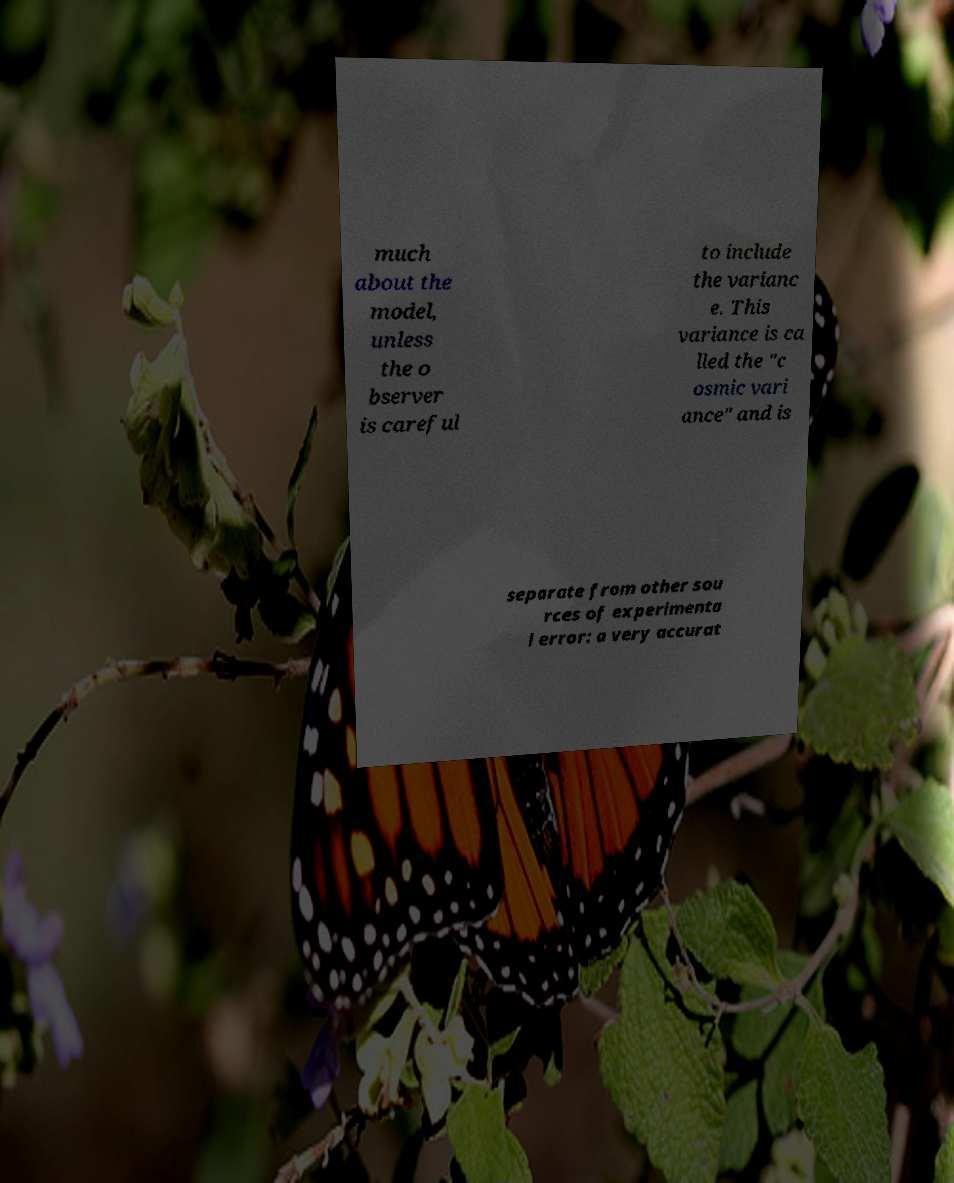Please read and relay the text visible in this image. What does it say? much about the model, unless the o bserver is careful to include the varianc e. This variance is ca lled the "c osmic vari ance" and is separate from other sou rces of experimenta l error: a very accurat 